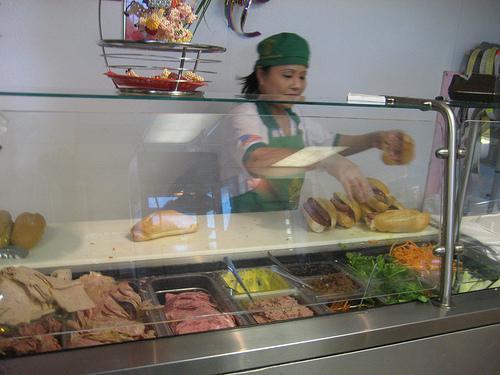How many people are pictureD?
Give a very brief answer. 1. 